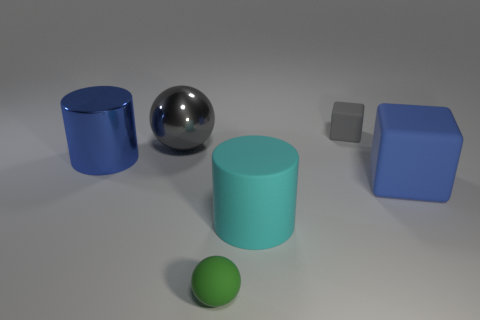There is a metal thing behind the big cylinder that is behind the matte cylinder; what is its shape?
Offer a terse response. Sphere. Are there any large gray balls?
Your response must be concise. Yes. What is the color of the small object behind the cyan matte cylinder?
Give a very brief answer. Gray. What material is the small cube that is the same color as the big shiny sphere?
Your response must be concise. Rubber. There is a blue shiny thing; are there any tiny matte blocks in front of it?
Offer a terse response. No. Is the number of big metallic cylinders greater than the number of big blue things?
Offer a terse response. No. There is a small matte thing in front of the large blue thing that is on the left side of the tiny matte object right of the matte cylinder; what is its color?
Offer a very short reply. Green. The large cylinder that is made of the same material as the large block is what color?
Ensure brevity in your answer.  Cyan. What number of things are either objects that are behind the blue rubber thing or things that are in front of the big metallic ball?
Your answer should be very brief. 6. There is a gray thing in front of the gray block; is it the same size as the blue object behind the large blue cube?
Provide a succinct answer. Yes. 